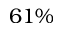Convert formula to latex. <formula><loc_0><loc_0><loc_500><loc_500>6 1 \%</formula> 